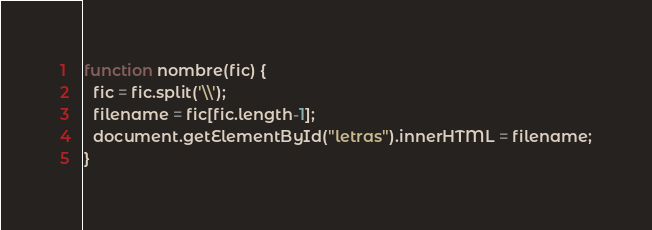<code> <loc_0><loc_0><loc_500><loc_500><_JavaScript_>function nombre(fic) {
  fic = fic.split('\\');
  filename = fic[fic.length-1];
  document.getElementById("letras").innerHTML = filename;
}</code> 